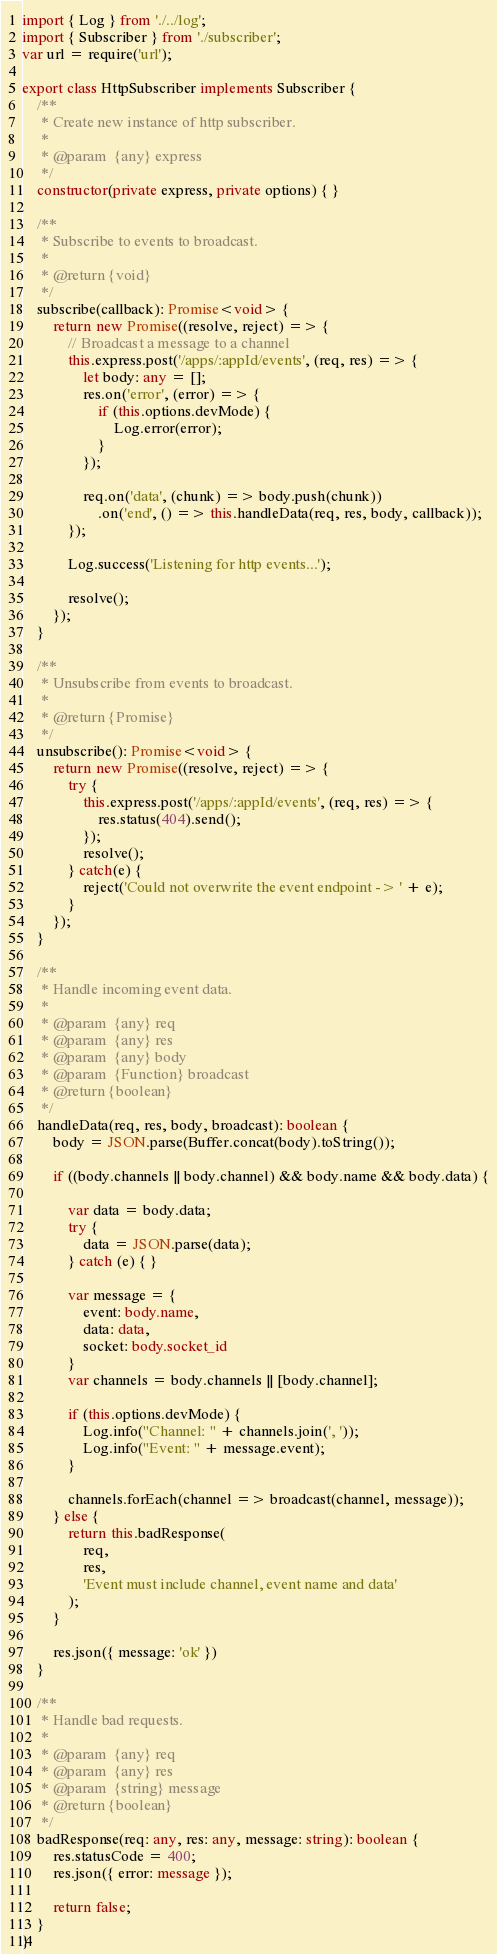<code> <loc_0><loc_0><loc_500><loc_500><_TypeScript_>import { Log } from './../log';
import { Subscriber } from './subscriber';
var url = require('url');

export class HttpSubscriber implements Subscriber {
    /**
     * Create new instance of http subscriber.
     *
     * @param  {any} express
     */
    constructor(private express, private options) { }

    /**
     * Subscribe to events to broadcast.
     *
     * @return {void}
     */
    subscribe(callback): Promise<void> {
        return new Promise((resolve, reject) => {
            // Broadcast a message to a channel
            this.express.post('/apps/:appId/events', (req, res) => {
                let body: any = [];
                res.on('error', (error) => {
                    if (this.options.devMode) {
                        Log.error(error);
                    }
                });

                req.on('data', (chunk) => body.push(chunk))
                    .on('end', () => this.handleData(req, res, body, callback));
            });

            Log.success('Listening for http events...');

            resolve();
        });
    }

    /**
     * Unsubscribe from events to broadcast.
     *
     * @return {Promise}
     */
    unsubscribe(): Promise<void> {
        return new Promise((resolve, reject) => {
            try {
                this.express.post('/apps/:appId/events', (req, res) => {
                    res.status(404).send();
                });
                resolve();
            } catch(e) {
                reject('Could not overwrite the event endpoint -> ' + e);
            }
        });
    }

    /**
     * Handle incoming event data.
     *
     * @param  {any} req
     * @param  {any} res
     * @param  {any} body
     * @param  {Function} broadcast
     * @return {boolean}
     */
    handleData(req, res, body, broadcast): boolean {
        body = JSON.parse(Buffer.concat(body).toString());

        if ((body.channels || body.channel) && body.name && body.data) {

            var data = body.data;
            try {
                data = JSON.parse(data);
            } catch (e) { }

            var message = {
                event: body.name,
                data: data,
                socket: body.socket_id
            }
            var channels = body.channels || [body.channel];

            if (this.options.devMode) {
                Log.info("Channel: " + channels.join(', '));
                Log.info("Event: " + message.event);
            }

            channels.forEach(channel => broadcast(channel, message));
        } else {
            return this.badResponse(
                req,
                res,
                'Event must include channel, event name and data'
            );
        }

        res.json({ message: 'ok' })
    }

    /**
     * Handle bad requests.
     *
     * @param  {any} req
     * @param  {any} res
     * @param  {string} message
     * @return {boolean}
     */
    badResponse(req: any, res: any, message: string): boolean {
        res.statusCode = 400;
        res.json({ error: message });

        return false;
    }
}
</code> 